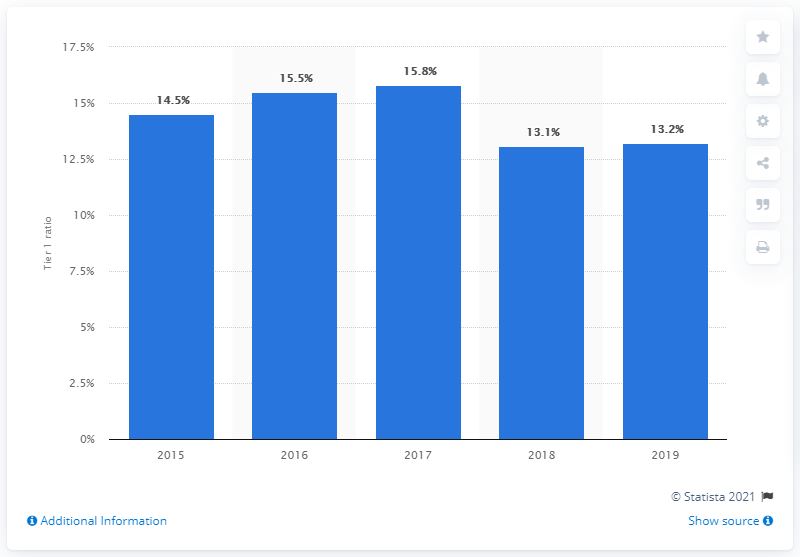Can you explain the significance of the Tier 1 ratio for banks? Certainly. The Tier 1 ratio is crucial because it measures a bank's core equity capital against its total risk-weighted assets. It is an essential metric of financial strength and stability, indicating a bank's ability to absorb losses and meet regulatory capital requirements without ceasing its operations. 